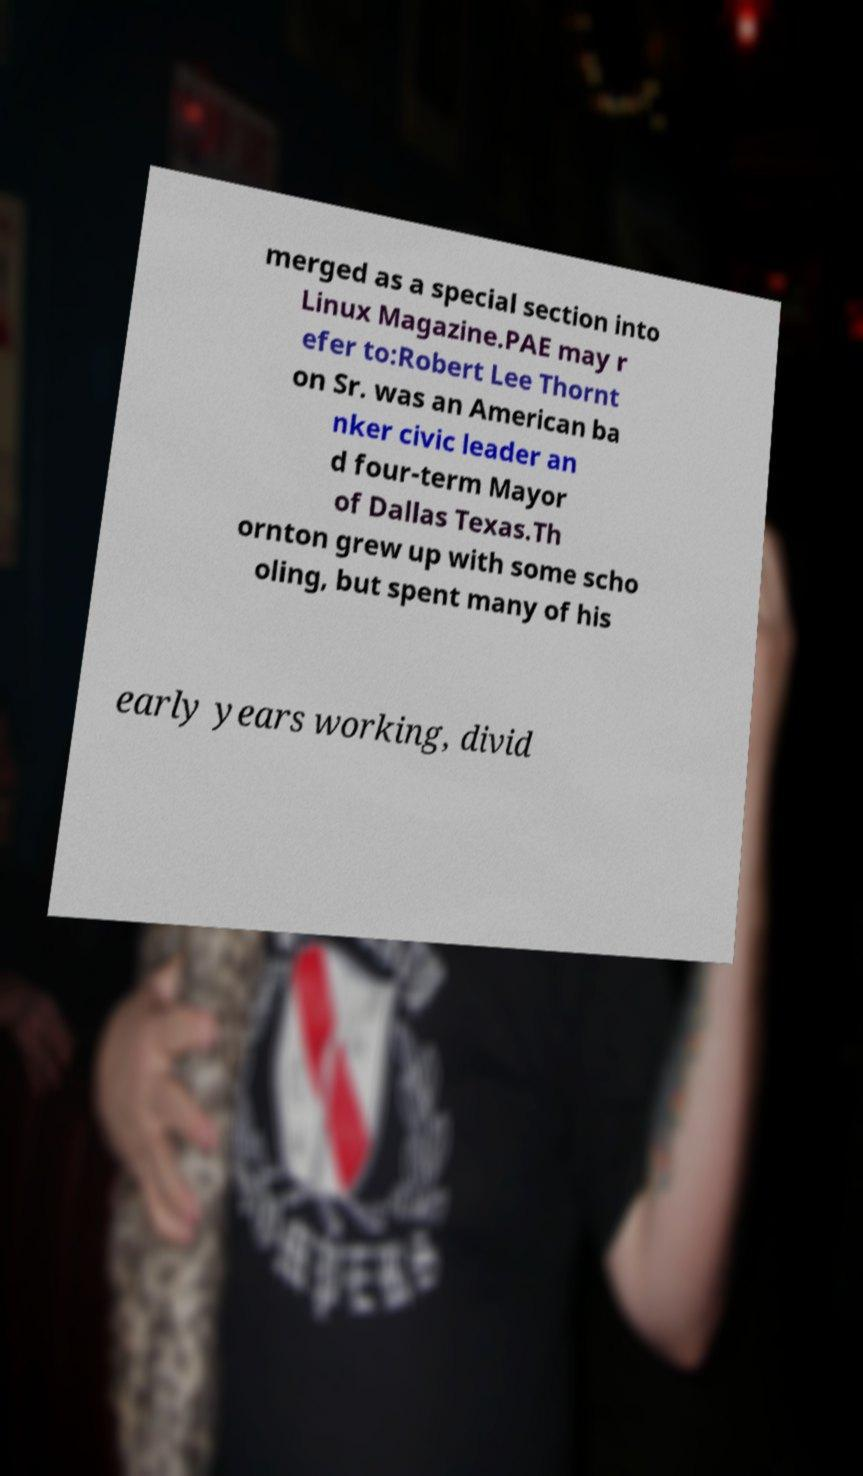Can you read and provide the text displayed in the image?This photo seems to have some interesting text. Can you extract and type it out for me? merged as a special section into Linux Magazine.PAE may r efer to:Robert Lee Thornt on Sr. was an American ba nker civic leader an d four-term Mayor of Dallas Texas.Th ornton grew up with some scho oling, but spent many of his early years working, divid 